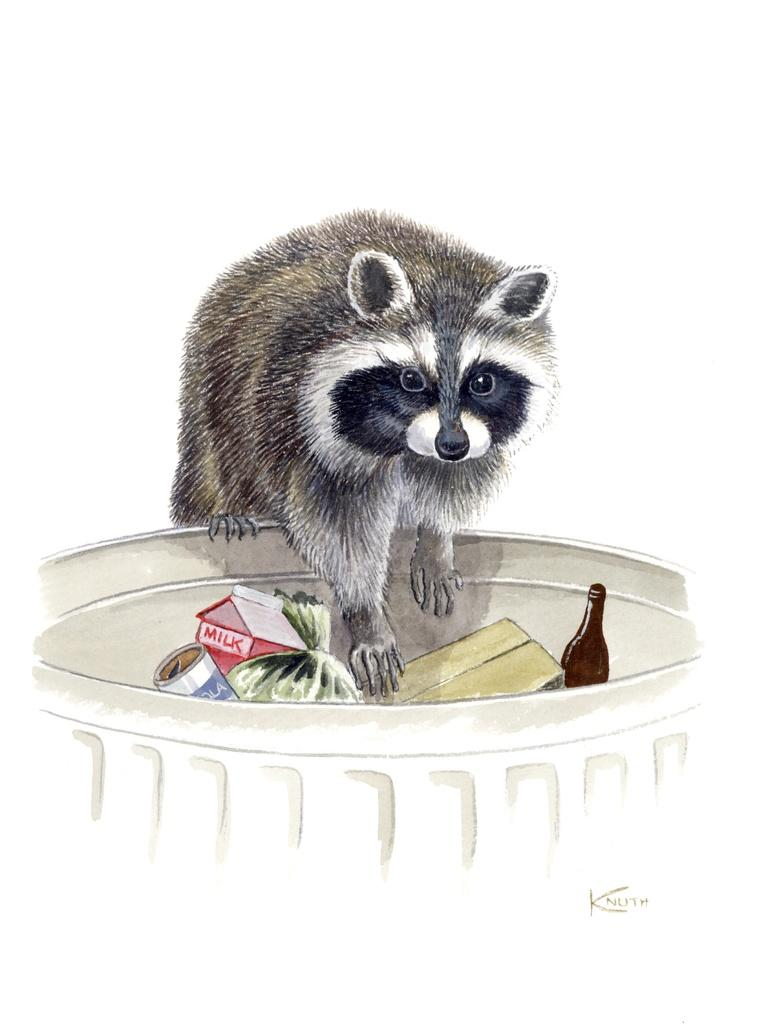What is depicted in the image? There is an art of an animal in the image. What else can be seen in the image besides the art of the animal? There are objects in a bin in the image. Is there any text present in the image? Yes, there is some text at the bottom of the image. Is the lawyer in the image arguing a case for the animal depicted in the art? There is no lawyer or any legal proceedings depicted in the image; it only features an art of an animal, objects in a bin, and some text. 